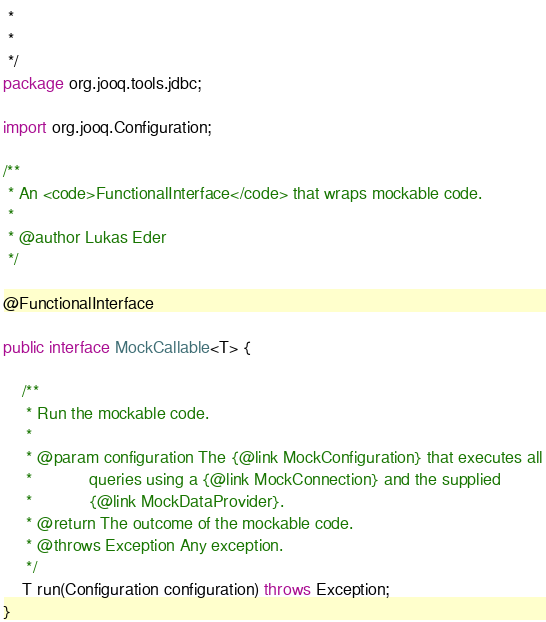Convert code to text. <code><loc_0><loc_0><loc_500><loc_500><_Java_> *
 *
 */
package org.jooq.tools.jdbc;

import org.jooq.Configuration;

/**
 * An <code>FunctionalInterface</code> that wraps mockable code.
 *
 * @author Lukas Eder
 */

@FunctionalInterface

public interface MockCallable<T> {

    /**
     * Run the mockable code.
     *
     * @param configuration The {@link MockConfiguration} that executes all
     *            queries using a {@link MockConnection} and the supplied
     *            {@link MockDataProvider}.
     * @return The outcome of the mockable code.
     * @throws Exception Any exception.
     */
    T run(Configuration configuration) throws Exception;
}
</code> 